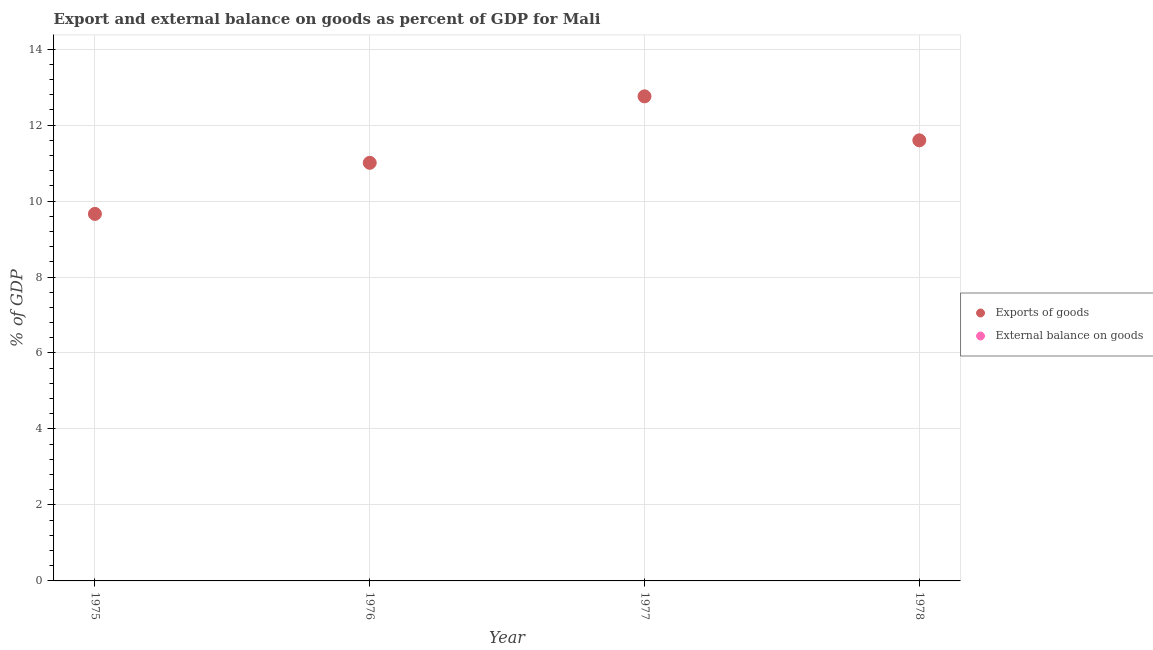How many different coloured dotlines are there?
Make the answer very short. 1. What is the export of goods as percentage of gdp in 1977?
Offer a very short reply. 12.76. Across all years, what is the maximum export of goods as percentage of gdp?
Offer a very short reply. 12.76. What is the total external balance on goods as percentage of gdp in the graph?
Ensure brevity in your answer.  0. What is the difference between the export of goods as percentage of gdp in 1976 and that in 1978?
Ensure brevity in your answer.  -0.59. What is the difference between the external balance on goods as percentage of gdp in 1976 and the export of goods as percentage of gdp in 1977?
Your answer should be compact. -12.76. What is the average export of goods as percentage of gdp per year?
Provide a succinct answer. 11.26. In how many years, is the external balance on goods as percentage of gdp greater than 1.2000000000000002 %?
Provide a short and direct response. 0. What is the ratio of the export of goods as percentage of gdp in 1976 to that in 1977?
Your answer should be very brief. 0.86. What is the difference between the highest and the second highest export of goods as percentage of gdp?
Ensure brevity in your answer.  1.16. What is the difference between the highest and the lowest export of goods as percentage of gdp?
Your answer should be compact. 3.09. In how many years, is the export of goods as percentage of gdp greater than the average export of goods as percentage of gdp taken over all years?
Offer a terse response. 2. Is the sum of the export of goods as percentage of gdp in 1975 and 1977 greater than the maximum external balance on goods as percentage of gdp across all years?
Provide a succinct answer. Yes. Is the export of goods as percentage of gdp strictly less than the external balance on goods as percentage of gdp over the years?
Give a very brief answer. No. What is the difference between two consecutive major ticks on the Y-axis?
Your answer should be compact. 2. Does the graph contain any zero values?
Provide a succinct answer. Yes. Does the graph contain grids?
Your response must be concise. Yes. What is the title of the graph?
Your answer should be very brief. Export and external balance on goods as percent of GDP for Mali. What is the label or title of the Y-axis?
Offer a terse response. % of GDP. What is the % of GDP of Exports of goods in 1975?
Keep it short and to the point. 9.66. What is the % of GDP in External balance on goods in 1975?
Your answer should be very brief. 0. What is the % of GDP of Exports of goods in 1976?
Your response must be concise. 11.01. What is the % of GDP of Exports of goods in 1977?
Offer a very short reply. 12.76. What is the % of GDP of Exports of goods in 1978?
Provide a short and direct response. 11.6. Across all years, what is the maximum % of GDP in Exports of goods?
Your answer should be very brief. 12.76. Across all years, what is the minimum % of GDP of Exports of goods?
Give a very brief answer. 9.66. What is the total % of GDP of Exports of goods in the graph?
Make the answer very short. 45.02. What is the difference between the % of GDP of Exports of goods in 1975 and that in 1976?
Keep it short and to the point. -1.34. What is the difference between the % of GDP of Exports of goods in 1975 and that in 1977?
Ensure brevity in your answer.  -3.09. What is the difference between the % of GDP of Exports of goods in 1975 and that in 1978?
Your answer should be very brief. -1.94. What is the difference between the % of GDP in Exports of goods in 1976 and that in 1977?
Your response must be concise. -1.75. What is the difference between the % of GDP of Exports of goods in 1976 and that in 1978?
Ensure brevity in your answer.  -0.59. What is the difference between the % of GDP in Exports of goods in 1977 and that in 1978?
Offer a terse response. 1.16. What is the average % of GDP in Exports of goods per year?
Give a very brief answer. 11.26. What is the ratio of the % of GDP of Exports of goods in 1975 to that in 1976?
Provide a short and direct response. 0.88. What is the ratio of the % of GDP in Exports of goods in 1975 to that in 1977?
Make the answer very short. 0.76. What is the ratio of the % of GDP in Exports of goods in 1975 to that in 1978?
Make the answer very short. 0.83. What is the ratio of the % of GDP in Exports of goods in 1976 to that in 1977?
Offer a terse response. 0.86. What is the ratio of the % of GDP of Exports of goods in 1976 to that in 1978?
Your answer should be very brief. 0.95. What is the ratio of the % of GDP in Exports of goods in 1977 to that in 1978?
Ensure brevity in your answer.  1.1. What is the difference between the highest and the second highest % of GDP of Exports of goods?
Provide a succinct answer. 1.16. What is the difference between the highest and the lowest % of GDP in Exports of goods?
Keep it short and to the point. 3.09. 